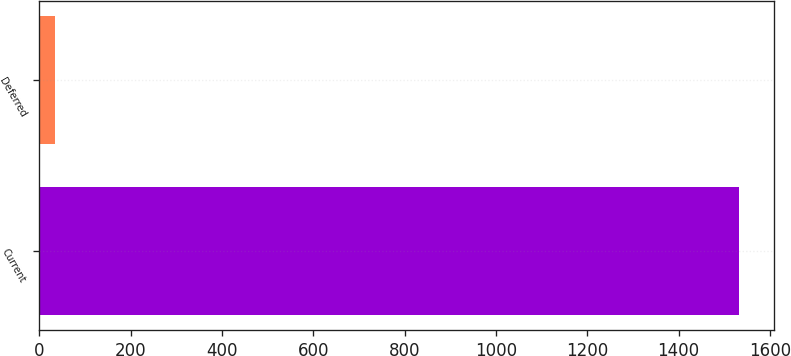Convert chart to OTSL. <chart><loc_0><loc_0><loc_500><loc_500><bar_chart><fcel>Current<fcel>Deferred<nl><fcel>1533<fcel>35<nl></chart> 